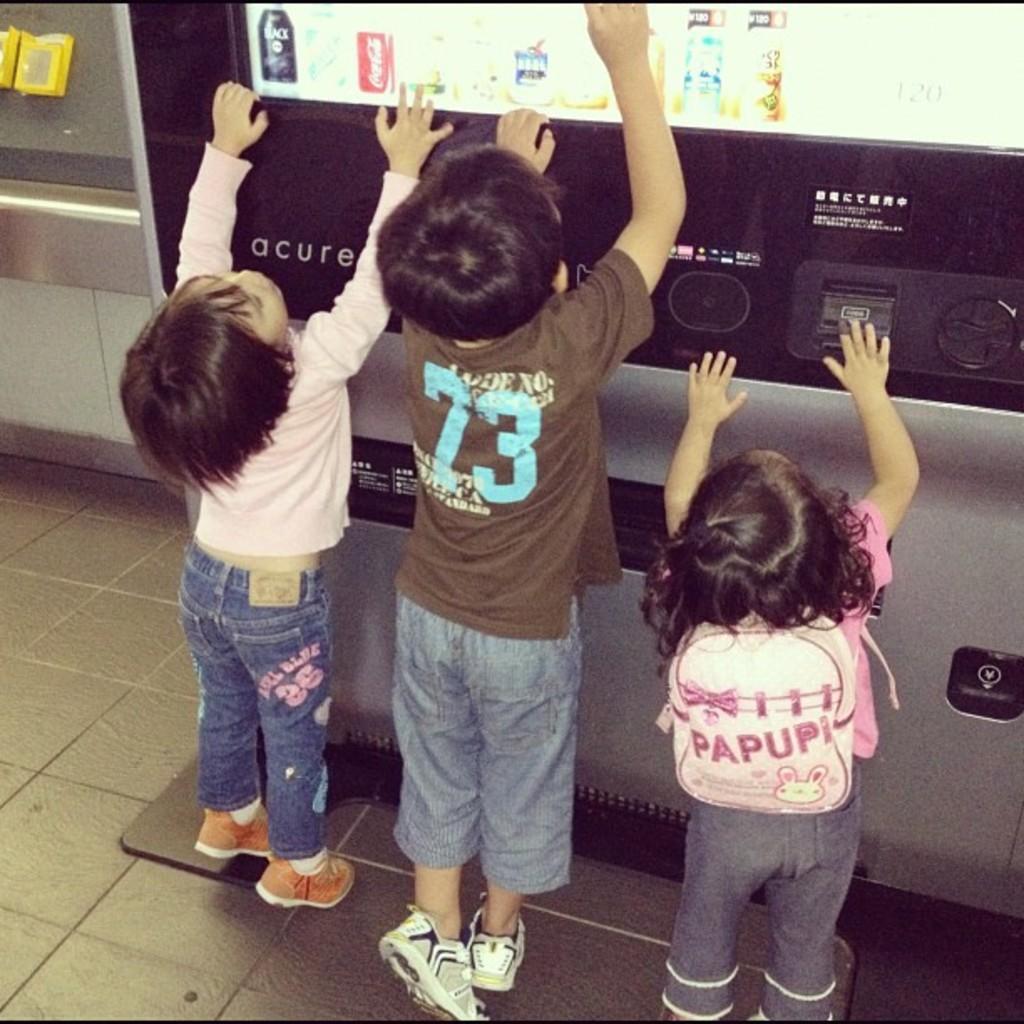Could you give a brief overview of what you see in this image? This image consists of three children. On the right, the girl is wearing a bag. At the bottom, there is a floor. In the front, there is a vending machine of snacks and cool drinks. 